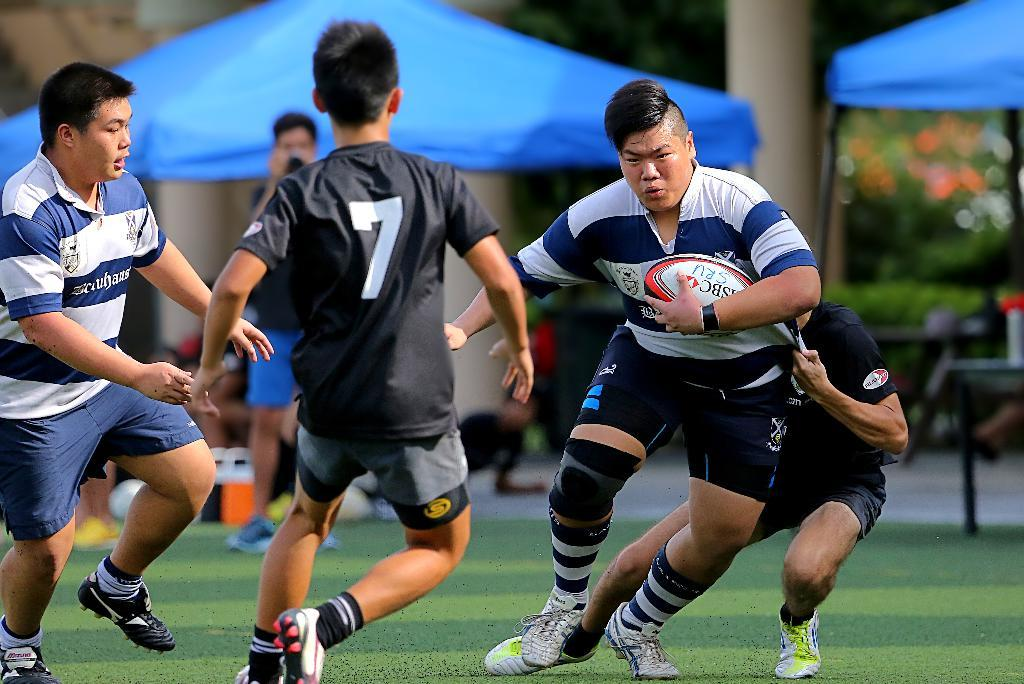How many people are in the image? There are four persons in the image. What are the persons doing in the image? The persons are walking. Can you describe any objects that one of the persons is holding? One of the persons is holding a ball. What can be seen in the distance in the image? There are tents in the distance. What color are the tents? The tents are blue in color. What type of toys can be seen scattered around the persons in the image? There are no toys visible in the image; the persons are walking and one is holding a ball. Can you tell me how many kittens are playing near the tents in the image? There are no kittens present in the image; only the persons, the ball, and the blue tents can be seen. 